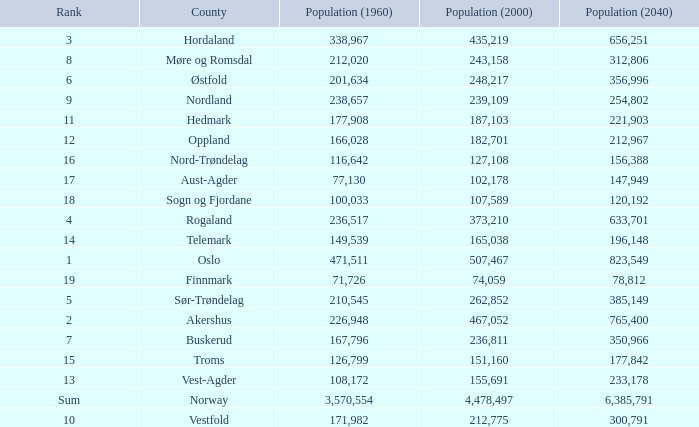What was Oslo's population in 1960, with a population of 507,467 in 2000? None. 